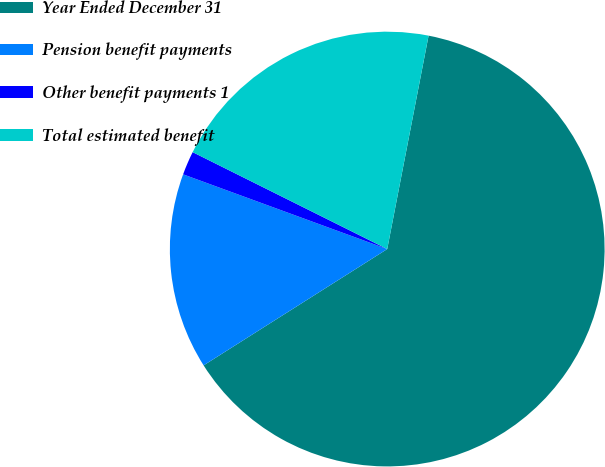Convert chart to OTSL. <chart><loc_0><loc_0><loc_500><loc_500><pie_chart><fcel>Year Ended December 31<fcel>Pension benefit payments<fcel>Other benefit payments 1<fcel>Total estimated benefit<nl><fcel>62.96%<fcel>14.57%<fcel>1.77%<fcel>20.69%<nl></chart> 